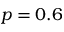<formula> <loc_0><loc_0><loc_500><loc_500>p = 0 . 6</formula> 